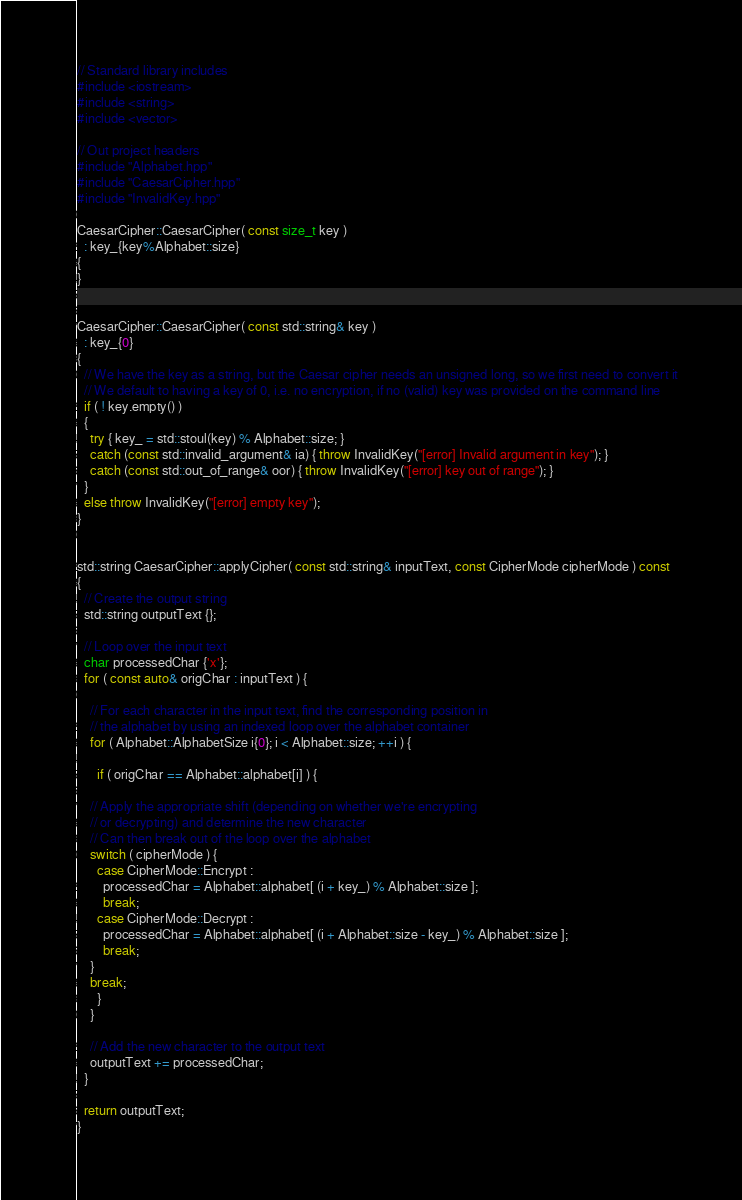<code> <loc_0><loc_0><loc_500><loc_500><_C++_>// Standard library includes
#include <iostream>
#include <string>
#include <vector>

// Out project headers
#include "Alphabet.hpp"
#include "CaesarCipher.hpp"
#include "InvalidKey.hpp"

CaesarCipher::CaesarCipher( const size_t key )
  : key_{key%Alphabet::size}
{
}


CaesarCipher::CaesarCipher( const std::string& key )
  : key_{0}
{
  // We have the key as a string, but the Caesar cipher needs an unsigned long, so we first need to convert it
  // We default to having a key of 0, i.e. no encryption, if no (valid) key was provided on the command line
  if ( ! key.empty() )
  {
    try { key_ = std::stoul(key) % Alphabet::size; }
    catch (const std::invalid_argument& ia) { throw InvalidKey("[error] Invalid argument in key"); }
    catch (const std::out_of_range& oor) { throw InvalidKey("[error] key out of range"); }
  }
  else throw InvalidKey("[error] empty key");
}


std::string CaesarCipher::applyCipher( const std::string& inputText, const CipherMode cipherMode ) const
{
  // Create the output string
  std::string outputText {};

  // Loop over the input text
  char processedChar {'x'};
  for ( const auto& origChar : inputText ) {

    // For each character in the input text, find the corresponding position in
    // the alphabet by using an indexed loop over the alphabet container
    for ( Alphabet::AlphabetSize i{0}; i < Alphabet::size; ++i ) {

      if ( origChar == Alphabet::alphabet[i] ) {

	// Apply the appropriate shift (depending on whether we're encrypting
	// or decrypting) and determine the new character
	// Can then break out of the loop over the alphabet
	switch ( cipherMode ) {
	  case CipherMode::Encrypt :
	    processedChar = Alphabet::alphabet[ (i + key_) % Alphabet::size ];
	    break;
	  case CipherMode::Decrypt :
	    processedChar = Alphabet::alphabet[ (i + Alphabet::size - key_) % Alphabet::size ];
	    break;
	}
	break;
      }
    }

    // Add the new character to the output text
    outputText += processedChar;
  }

  return outputText;
}
</code> 